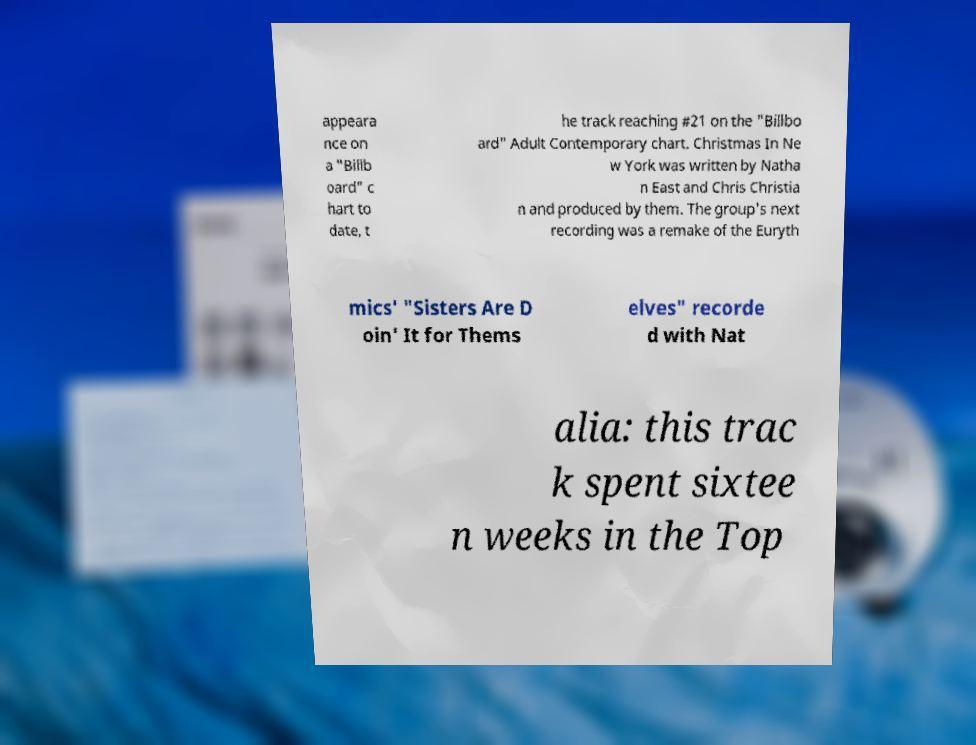For documentation purposes, I need the text within this image transcribed. Could you provide that? appeara nce on a "Billb oard" c hart to date, t he track reaching #21 on the "Billbo ard" Adult Contemporary chart. Christmas In Ne w York was written by Natha n East and Chris Christia n and produced by them. The group's next recording was a remake of the Euryth mics' "Sisters Are D oin' It for Thems elves" recorde d with Nat alia: this trac k spent sixtee n weeks in the Top 